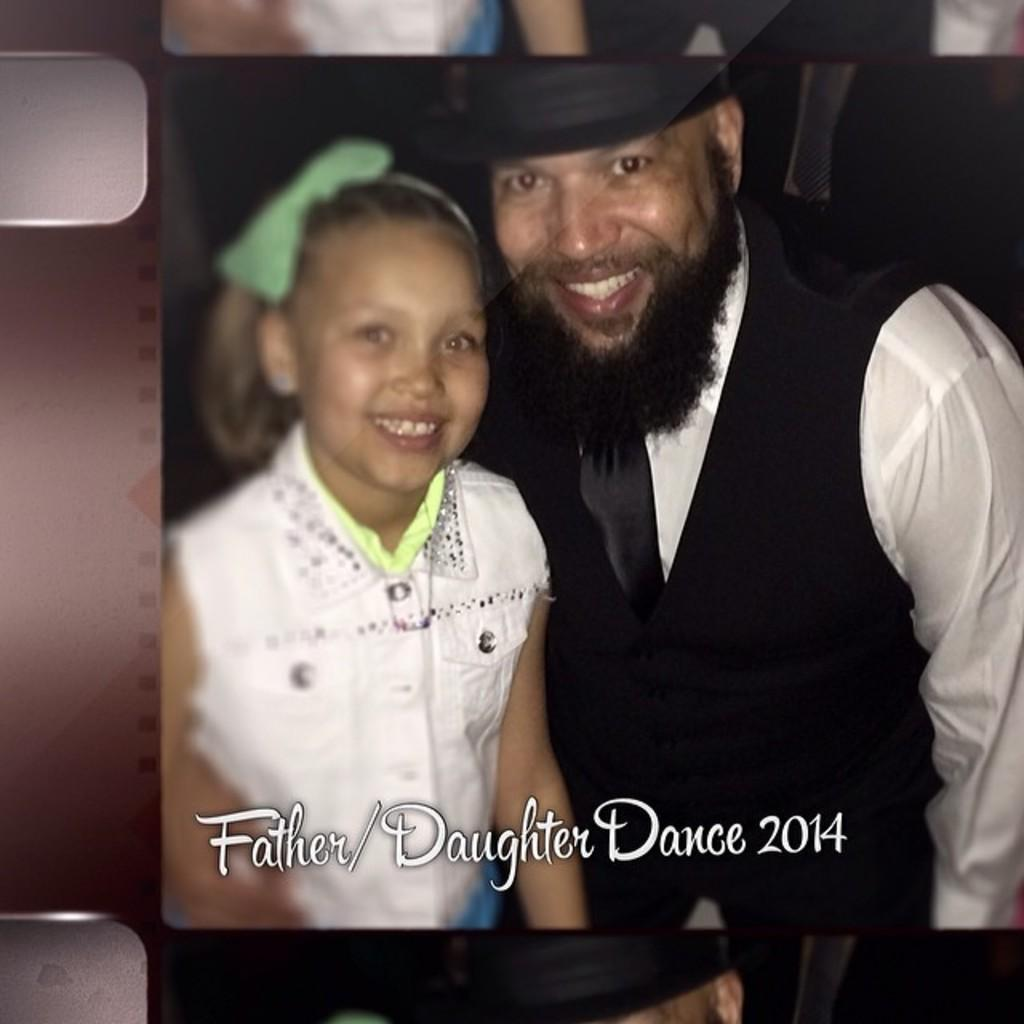Who is present in the image? There is a person in the image. Can you describe the person in the image? There is a girl in the image. What else can be seen in the image besides the girl? There is text on the image. What type of furniture is being hammered by the girl in the image? There is no furniture or hammer present in the image. What subject is being taught in the school depicted in the image? There is no school depicted in the image. 